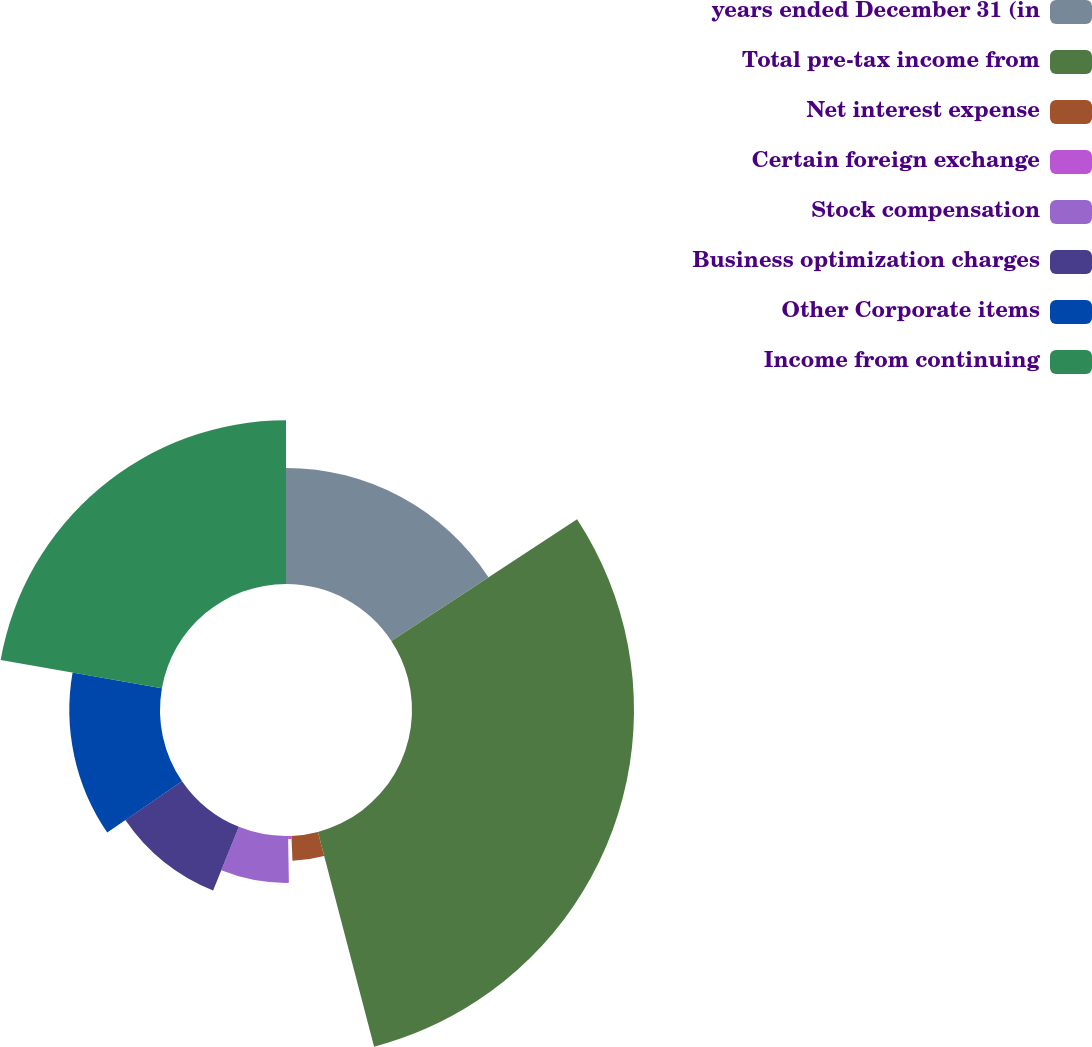Convert chart to OTSL. <chart><loc_0><loc_0><loc_500><loc_500><pie_chart><fcel>years ended December 31 (in<fcel>Total pre-tax income from<fcel>Net interest expense<fcel>Certain foreign exchange<fcel>Stock compensation<fcel>Business optimization charges<fcel>Other Corporate items<fcel>Income from continuing<nl><fcel>15.77%<fcel>30.16%<fcel>3.39%<fcel>0.42%<fcel>6.37%<fcel>9.34%<fcel>12.32%<fcel>22.24%<nl></chart> 